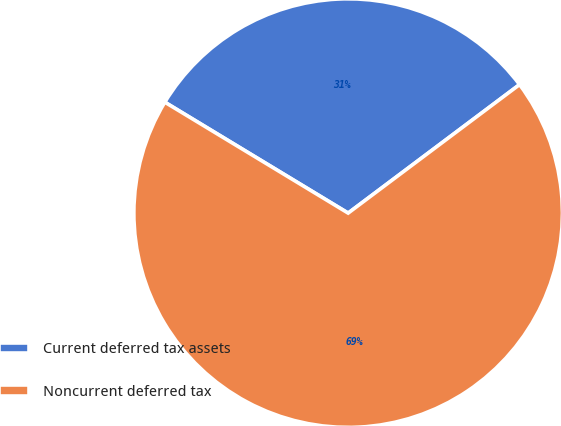<chart> <loc_0><loc_0><loc_500><loc_500><pie_chart><fcel>Current deferred tax assets<fcel>Noncurrent deferred tax<nl><fcel>31.1%<fcel>68.9%<nl></chart> 